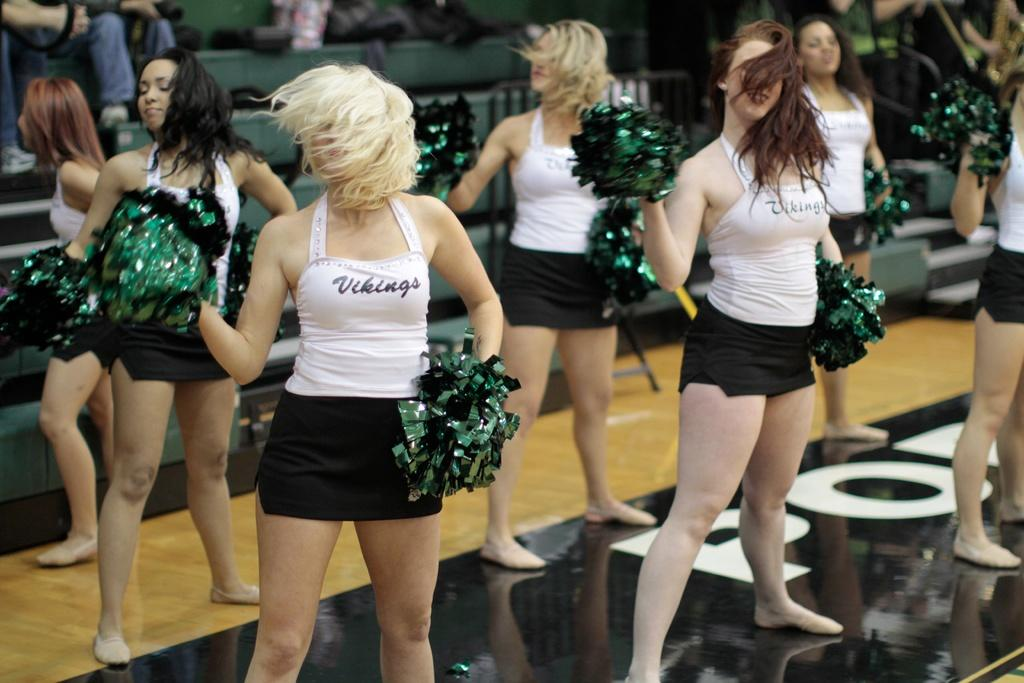<image>
Give a short and clear explanation of the subsequent image. Cheer leaders are dancing on a basketball court and their shirts say Vikings. 